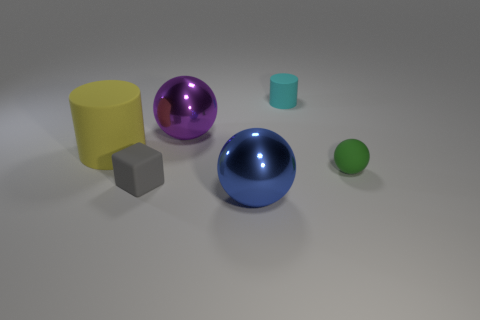Does the rubber object on the right side of the cyan matte object have the same shape as the large blue metallic thing?
Your response must be concise. Yes. What size is the cyan object that is the same material as the small cube?
Your response must be concise. Small. How many things are either spheres that are right of the tiny cyan cylinder or things on the right side of the large cylinder?
Make the answer very short. 5. Is the number of small cyan things that are to the right of the gray cube the same as the number of objects on the left side of the small matte sphere?
Your answer should be very brief. No. There is a small matte thing that is to the right of the cyan thing; what color is it?
Provide a short and direct response. Green. Are there fewer large blue metal balls than big blue rubber objects?
Provide a succinct answer. No. There is a small rubber object left of the purple shiny thing; does it have the same color as the small ball?
Provide a short and direct response. No. How many yellow rubber spheres are the same size as the cyan object?
Your answer should be very brief. 0. Does the small gray thing have the same material as the cyan object?
Give a very brief answer. Yes. What number of tiny things are the same shape as the large yellow object?
Your response must be concise. 1. 